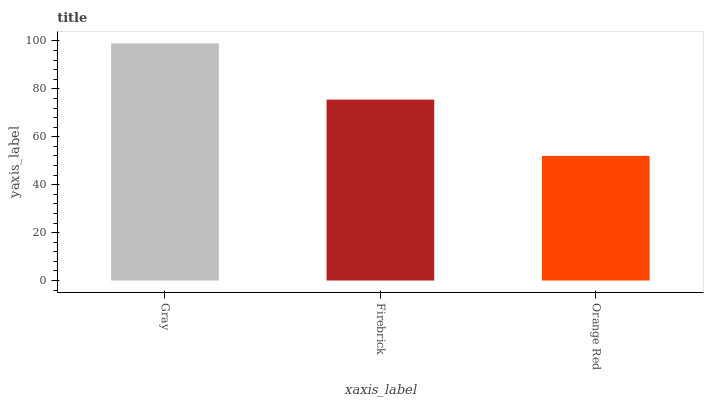Is Firebrick the minimum?
Answer yes or no. No. Is Firebrick the maximum?
Answer yes or no. No. Is Gray greater than Firebrick?
Answer yes or no. Yes. Is Firebrick less than Gray?
Answer yes or no. Yes. Is Firebrick greater than Gray?
Answer yes or no. No. Is Gray less than Firebrick?
Answer yes or no. No. Is Firebrick the high median?
Answer yes or no. Yes. Is Firebrick the low median?
Answer yes or no. Yes. Is Gray the high median?
Answer yes or no. No. Is Orange Red the low median?
Answer yes or no. No. 